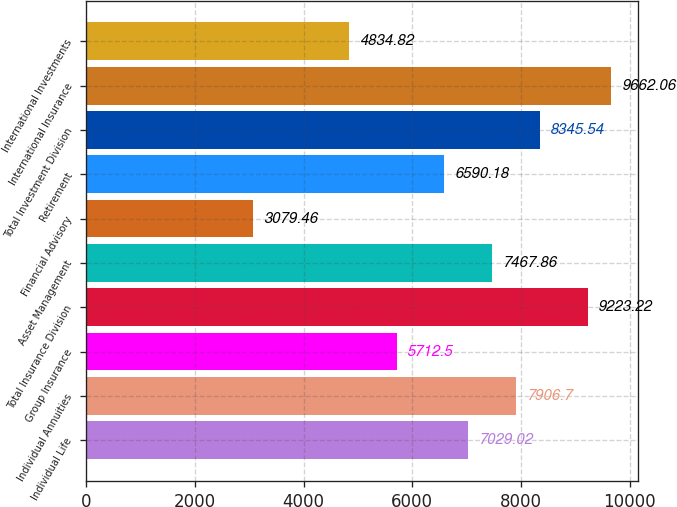Convert chart. <chart><loc_0><loc_0><loc_500><loc_500><bar_chart><fcel>Individual Life<fcel>Individual Annuities<fcel>Group Insurance<fcel>Total Insurance Division<fcel>Asset Management<fcel>Financial Advisory<fcel>Retirement<fcel>Total Investment Division<fcel>International Insurance<fcel>International Investments<nl><fcel>7029.02<fcel>7906.7<fcel>5712.5<fcel>9223.22<fcel>7467.86<fcel>3079.46<fcel>6590.18<fcel>8345.54<fcel>9662.06<fcel>4834.82<nl></chart> 